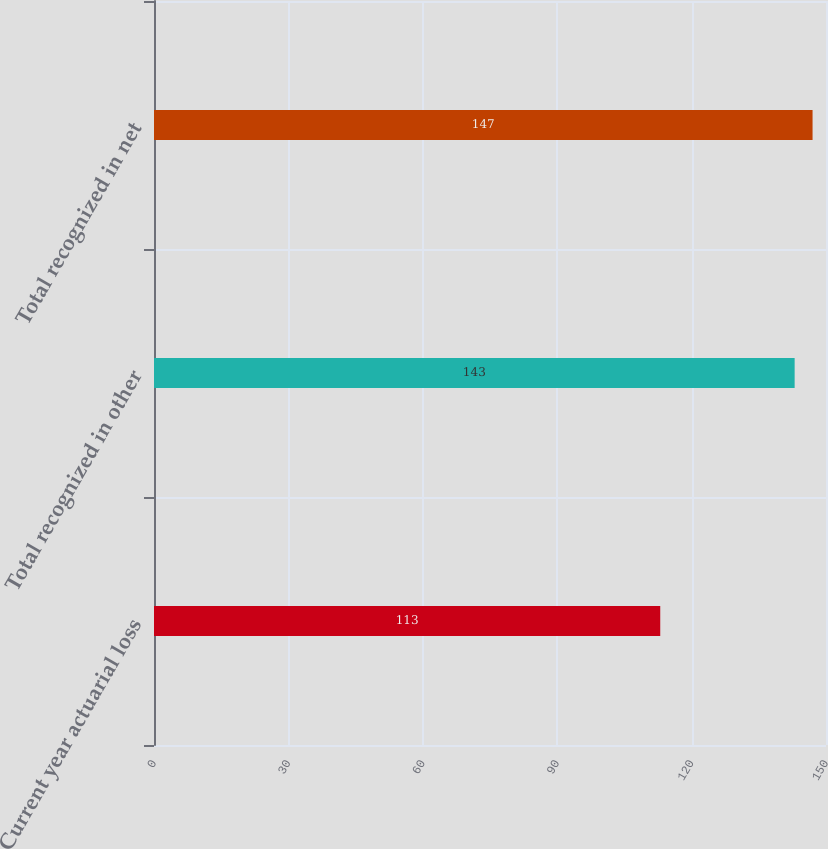<chart> <loc_0><loc_0><loc_500><loc_500><bar_chart><fcel>Current year actuarial loss<fcel>Total recognized in other<fcel>Total recognized in net<nl><fcel>113<fcel>143<fcel>147<nl></chart> 